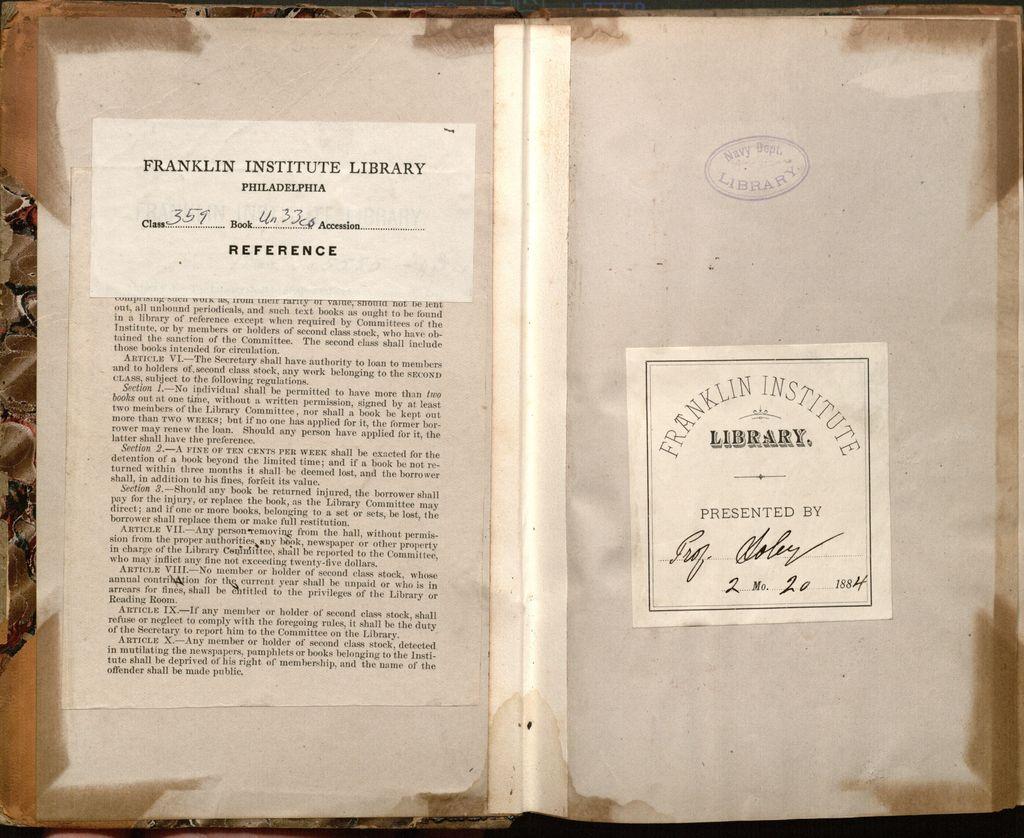Which library did the book come from?
Ensure brevity in your answer.  Franklin institute. What are the numbers in the reference?
Ensure brevity in your answer.  359. 